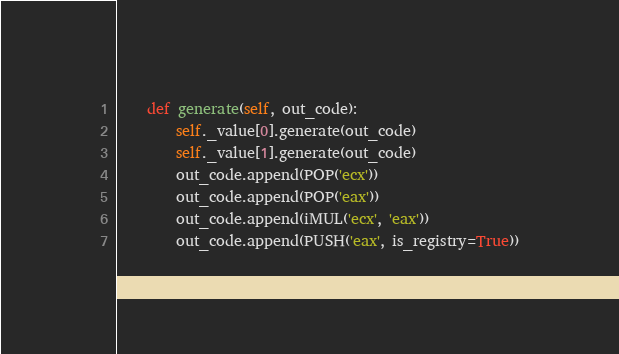Convert code to text. <code><loc_0><loc_0><loc_500><loc_500><_Python_>
    def generate(self, out_code):
        self._value[0].generate(out_code)
        self._value[1].generate(out_code)
        out_code.append(POP('ecx'))
        out_code.append(POP('eax'))
        out_code.append(iMUL('ecx', 'eax'))
        out_code.append(PUSH('eax', is_registry=True))

</code> 